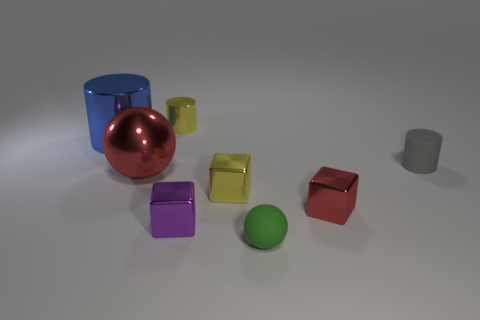Subtract all yellow metallic blocks. How many blocks are left? 2 Add 1 large green cubes. How many objects exist? 9 Subtract 1 green spheres. How many objects are left? 7 Subtract all cubes. How many objects are left? 5 Subtract 3 cylinders. How many cylinders are left? 0 Subtract all purple cylinders. Subtract all gray balls. How many cylinders are left? 3 Subtract all blue blocks. How many purple spheres are left? 0 Subtract all small purple matte spheres. Subtract all green things. How many objects are left? 7 Add 6 tiny yellow cylinders. How many tiny yellow cylinders are left? 7 Add 6 purple cylinders. How many purple cylinders exist? 6 